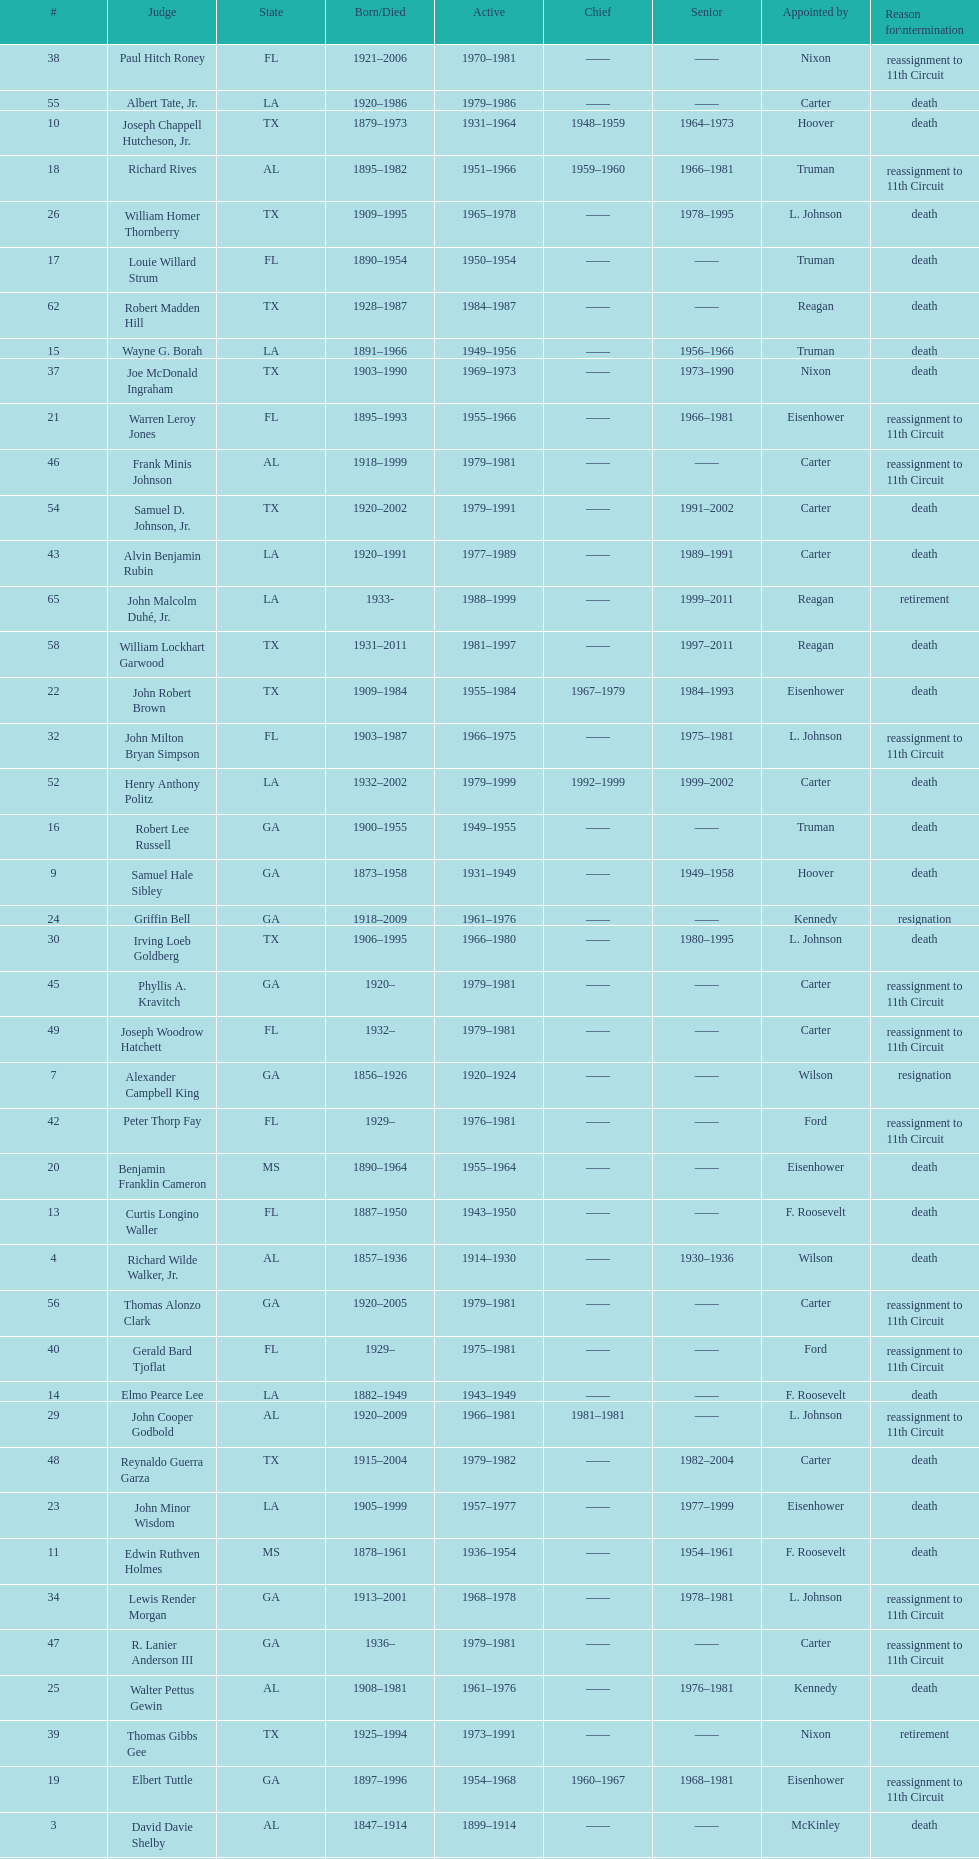Which state has the largest amount of judges to serve? TX. 